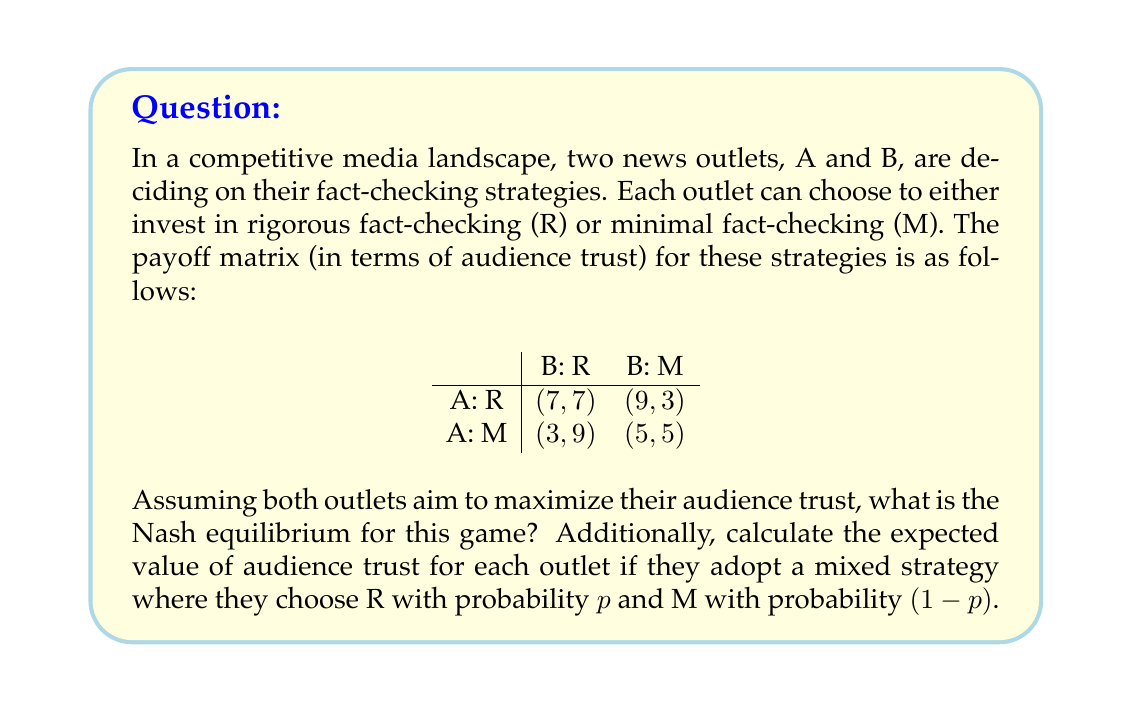Can you solve this math problem? To solve this game theory problem, we'll follow these steps:

1. Determine the Nash equilibrium:
   For a Nash equilibrium, neither player should have an incentive to unilaterally change their strategy.

   If B chooses R:
   A's payoff for R: 7
   A's payoff for M: 3
   A prefers R

   If B chooses M:
   A's payoff for R: 9
   A's payoff for M: 5
   A prefers R

   Similarly, for B:
   If A chooses R, B prefers R (7 > 3)
   If A chooses M, B prefers R (9 > 5)

   Therefore, the Nash equilibrium is (R, R), where both outlets choose rigorous fact-checking.

2. Calculate the expected value for mixed strategies:
   Let $p_A$ and $p_B$ be the probabilities of choosing R for A and B respectively.

   Expected value for A:
   $$E_A = 7p_Ap_B + 9p_A(1-p_B) + 3(1-p_A)p_B + 5(1-p_A)(1-p_B)$$

   Expected value for B:
   $$E_B = 7p_Ap_B + 3p_A(1-p_B) + 9(1-p_A)p_B + 5(1-p_A)(1-p_B)$$

   To find the optimal mixed strategy, we set the partial derivatives to zero:

   $$\frac{\partial E_A}{\partial p_A} = 7p_B + 9(1-p_B) - 3p_B - 5(1-p_B) = 0$$
   $$\frac{\partial E_B}{\partial p_B} = 7p_A + 3(1-p_A) - 9p_A - 5(1-p_A) = 0$$

   Solving these equations:
   $$4p_B = 4$$
   $$p_B = 1$$

   $$-8p_A + 2 = 0$$
   $$p_A = \frac{1}{4}$$

   However, since $p_B = 1$, this is not a true mixed strategy for B. The optimal strategy is for B to always choose R, and for A to choose R with probability 1 (pure strategy).

   The expected values for this strategy are:
   $$E_A = 7 \cdot 1 \cdot 1 = 7$$
   $$E_B = 7 \cdot 1 \cdot 1 = 7$$
Answer: The Nash equilibrium is (R, R), where both outlets choose rigorous fact-checking. The expected value of audience trust for each outlet in this equilibrium is 7. 